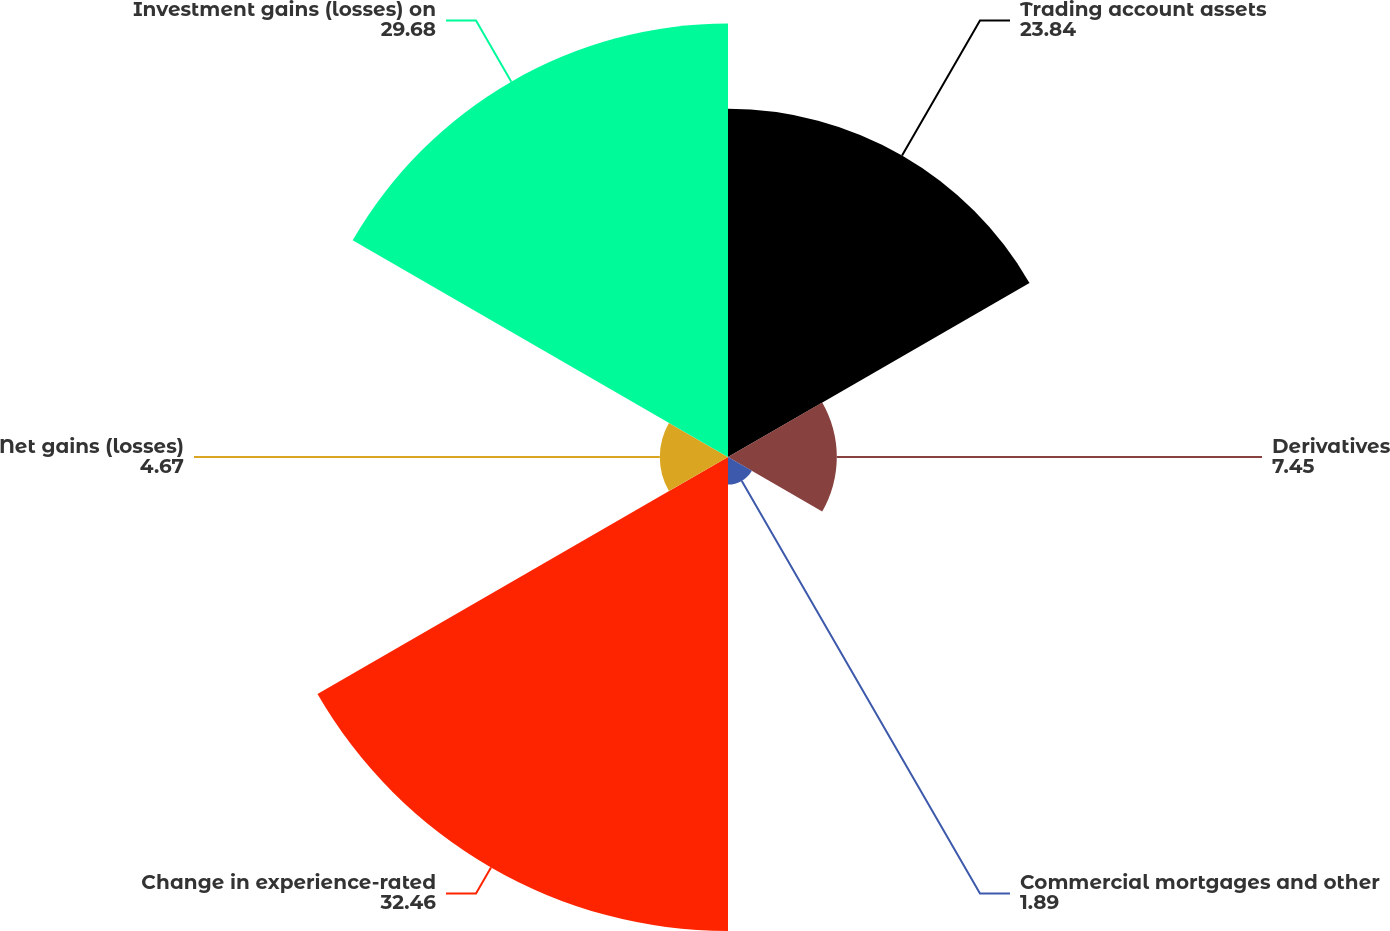Convert chart. <chart><loc_0><loc_0><loc_500><loc_500><pie_chart><fcel>Trading account assets<fcel>Derivatives<fcel>Commercial mortgages and other<fcel>Change in experience-rated<fcel>Net gains (losses)<fcel>Investment gains (losses) on<nl><fcel>23.84%<fcel>7.45%<fcel>1.89%<fcel>32.46%<fcel>4.67%<fcel>29.68%<nl></chart> 